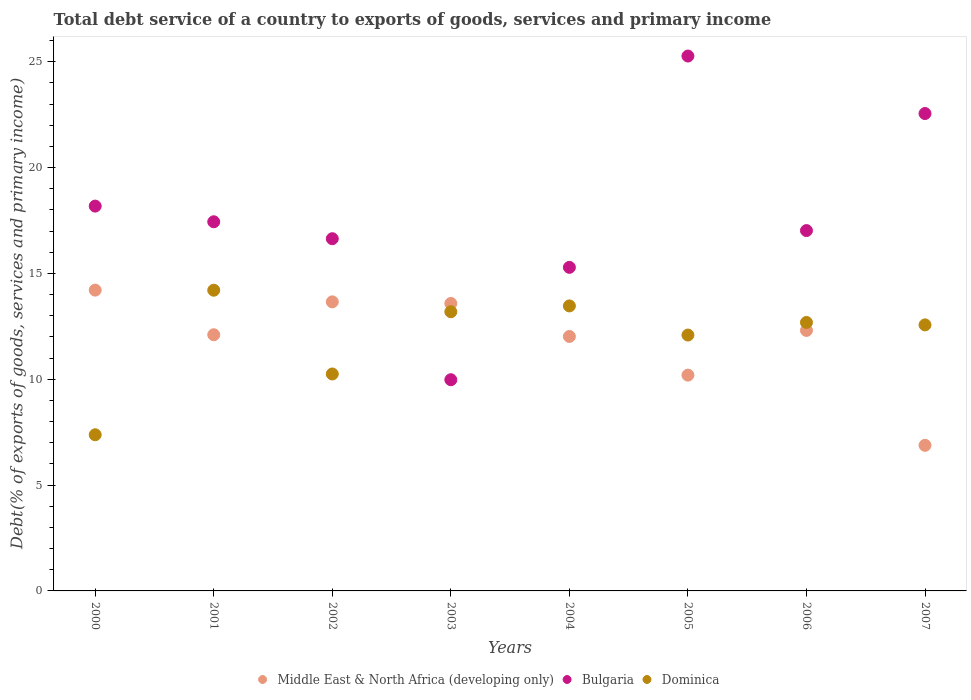Is the number of dotlines equal to the number of legend labels?
Make the answer very short. Yes. What is the total debt service in Bulgaria in 2000?
Your response must be concise. 18.18. Across all years, what is the maximum total debt service in Bulgaria?
Your response must be concise. 25.27. Across all years, what is the minimum total debt service in Bulgaria?
Make the answer very short. 9.98. What is the total total debt service in Middle East & North Africa (developing only) in the graph?
Make the answer very short. 94.96. What is the difference between the total debt service in Middle East & North Africa (developing only) in 2003 and that in 2005?
Your answer should be compact. 3.39. What is the difference between the total debt service in Bulgaria in 2004 and the total debt service in Dominica in 2007?
Provide a succinct answer. 2.72. What is the average total debt service in Bulgaria per year?
Offer a very short reply. 17.8. In the year 2004, what is the difference between the total debt service in Bulgaria and total debt service in Dominica?
Provide a short and direct response. 1.82. In how many years, is the total debt service in Bulgaria greater than 2 %?
Your answer should be compact. 8. What is the ratio of the total debt service in Middle East & North Africa (developing only) in 2003 to that in 2006?
Provide a succinct answer. 1.1. What is the difference between the highest and the second highest total debt service in Middle East & North Africa (developing only)?
Keep it short and to the point. 0.55. What is the difference between the highest and the lowest total debt service in Middle East & North Africa (developing only)?
Provide a short and direct response. 7.33. Does the total debt service in Dominica monotonically increase over the years?
Provide a short and direct response. No. How many years are there in the graph?
Provide a short and direct response. 8. What is the difference between two consecutive major ticks on the Y-axis?
Ensure brevity in your answer.  5. Are the values on the major ticks of Y-axis written in scientific E-notation?
Make the answer very short. No. Where does the legend appear in the graph?
Your answer should be very brief. Bottom center. How many legend labels are there?
Your answer should be compact. 3. What is the title of the graph?
Your response must be concise. Total debt service of a country to exports of goods, services and primary income. Does "Suriname" appear as one of the legend labels in the graph?
Give a very brief answer. No. What is the label or title of the Y-axis?
Keep it short and to the point. Debt(% of exports of goods, services and primary income). What is the Debt(% of exports of goods, services and primary income) of Middle East & North Africa (developing only) in 2000?
Offer a terse response. 14.21. What is the Debt(% of exports of goods, services and primary income) of Bulgaria in 2000?
Provide a short and direct response. 18.18. What is the Debt(% of exports of goods, services and primary income) of Dominica in 2000?
Make the answer very short. 7.38. What is the Debt(% of exports of goods, services and primary income) of Middle East & North Africa (developing only) in 2001?
Offer a terse response. 12.1. What is the Debt(% of exports of goods, services and primary income) of Bulgaria in 2001?
Your response must be concise. 17.44. What is the Debt(% of exports of goods, services and primary income) in Dominica in 2001?
Provide a succinct answer. 14.21. What is the Debt(% of exports of goods, services and primary income) of Middle East & North Africa (developing only) in 2002?
Provide a succinct answer. 13.66. What is the Debt(% of exports of goods, services and primary income) of Bulgaria in 2002?
Make the answer very short. 16.64. What is the Debt(% of exports of goods, services and primary income) in Dominica in 2002?
Offer a very short reply. 10.25. What is the Debt(% of exports of goods, services and primary income) in Middle East & North Africa (developing only) in 2003?
Offer a terse response. 13.58. What is the Debt(% of exports of goods, services and primary income) in Bulgaria in 2003?
Your answer should be compact. 9.98. What is the Debt(% of exports of goods, services and primary income) in Dominica in 2003?
Give a very brief answer. 13.19. What is the Debt(% of exports of goods, services and primary income) of Middle East & North Africa (developing only) in 2004?
Keep it short and to the point. 12.02. What is the Debt(% of exports of goods, services and primary income) in Bulgaria in 2004?
Your response must be concise. 15.29. What is the Debt(% of exports of goods, services and primary income) of Dominica in 2004?
Provide a short and direct response. 13.47. What is the Debt(% of exports of goods, services and primary income) in Middle East & North Africa (developing only) in 2005?
Give a very brief answer. 10.2. What is the Debt(% of exports of goods, services and primary income) of Bulgaria in 2005?
Ensure brevity in your answer.  25.27. What is the Debt(% of exports of goods, services and primary income) in Dominica in 2005?
Make the answer very short. 12.09. What is the Debt(% of exports of goods, services and primary income) in Middle East & North Africa (developing only) in 2006?
Provide a succinct answer. 12.31. What is the Debt(% of exports of goods, services and primary income) in Bulgaria in 2006?
Your answer should be compact. 17.03. What is the Debt(% of exports of goods, services and primary income) of Dominica in 2006?
Your answer should be very brief. 12.68. What is the Debt(% of exports of goods, services and primary income) in Middle East & North Africa (developing only) in 2007?
Provide a succinct answer. 6.88. What is the Debt(% of exports of goods, services and primary income) in Bulgaria in 2007?
Provide a succinct answer. 22.56. What is the Debt(% of exports of goods, services and primary income) in Dominica in 2007?
Ensure brevity in your answer.  12.57. Across all years, what is the maximum Debt(% of exports of goods, services and primary income) of Middle East & North Africa (developing only)?
Provide a short and direct response. 14.21. Across all years, what is the maximum Debt(% of exports of goods, services and primary income) in Bulgaria?
Give a very brief answer. 25.27. Across all years, what is the maximum Debt(% of exports of goods, services and primary income) in Dominica?
Keep it short and to the point. 14.21. Across all years, what is the minimum Debt(% of exports of goods, services and primary income) in Middle East & North Africa (developing only)?
Give a very brief answer. 6.88. Across all years, what is the minimum Debt(% of exports of goods, services and primary income) of Bulgaria?
Provide a succinct answer. 9.98. Across all years, what is the minimum Debt(% of exports of goods, services and primary income) of Dominica?
Your response must be concise. 7.38. What is the total Debt(% of exports of goods, services and primary income) of Middle East & North Africa (developing only) in the graph?
Your answer should be very brief. 94.96. What is the total Debt(% of exports of goods, services and primary income) of Bulgaria in the graph?
Your response must be concise. 142.39. What is the total Debt(% of exports of goods, services and primary income) of Dominica in the graph?
Your response must be concise. 95.84. What is the difference between the Debt(% of exports of goods, services and primary income) in Middle East & North Africa (developing only) in 2000 and that in 2001?
Your answer should be compact. 2.11. What is the difference between the Debt(% of exports of goods, services and primary income) of Bulgaria in 2000 and that in 2001?
Keep it short and to the point. 0.74. What is the difference between the Debt(% of exports of goods, services and primary income) of Dominica in 2000 and that in 2001?
Make the answer very short. -6.83. What is the difference between the Debt(% of exports of goods, services and primary income) in Middle East & North Africa (developing only) in 2000 and that in 2002?
Provide a succinct answer. 0.55. What is the difference between the Debt(% of exports of goods, services and primary income) of Bulgaria in 2000 and that in 2002?
Ensure brevity in your answer.  1.54. What is the difference between the Debt(% of exports of goods, services and primary income) of Dominica in 2000 and that in 2002?
Provide a succinct answer. -2.87. What is the difference between the Debt(% of exports of goods, services and primary income) in Middle East & North Africa (developing only) in 2000 and that in 2003?
Keep it short and to the point. 0.63. What is the difference between the Debt(% of exports of goods, services and primary income) of Bulgaria in 2000 and that in 2003?
Ensure brevity in your answer.  8.2. What is the difference between the Debt(% of exports of goods, services and primary income) in Dominica in 2000 and that in 2003?
Your response must be concise. -5.81. What is the difference between the Debt(% of exports of goods, services and primary income) of Middle East & North Africa (developing only) in 2000 and that in 2004?
Make the answer very short. 2.19. What is the difference between the Debt(% of exports of goods, services and primary income) of Bulgaria in 2000 and that in 2004?
Offer a terse response. 2.89. What is the difference between the Debt(% of exports of goods, services and primary income) of Dominica in 2000 and that in 2004?
Offer a very short reply. -6.09. What is the difference between the Debt(% of exports of goods, services and primary income) of Middle East & North Africa (developing only) in 2000 and that in 2005?
Offer a very short reply. 4.02. What is the difference between the Debt(% of exports of goods, services and primary income) in Bulgaria in 2000 and that in 2005?
Your response must be concise. -7.09. What is the difference between the Debt(% of exports of goods, services and primary income) of Dominica in 2000 and that in 2005?
Offer a terse response. -4.71. What is the difference between the Debt(% of exports of goods, services and primary income) in Middle East & North Africa (developing only) in 2000 and that in 2006?
Keep it short and to the point. 1.91. What is the difference between the Debt(% of exports of goods, services and primary income) in Bulgaria in 2000 and that in 2006?
Provide a short and direct response. 1.16. What is the difference between the Debt(% of exports of goods, services and primary income) in Dominica in 2000 and that in 2006?
Make the answer very short. -5.31. What is the difference between the Debt(% of exports of goods, services and primary income) of Middle East & North Africa (developing only) in 2000 and that in 2007?
Your response must be concise. 7.33. What is the difference between the Debt(% of exports of goods, services and primary income) of Bulgaria in 2000 and that in 2007?
Provide a succinct answer. -4.37. What is the difference between the Debt(% of exports of goods, services and primary income) of Dominica in 2000 and that in 2007?
Keep it short and to the point. -5.19. What is the difference between the Debt(% of exports of goods, services and primary income) of Middle East & North Africa (developing only) in 2001 and that in 2002?
Keep it short and to the point. -1.55. What is the difference between the Debt(% of exports of goods, services and primary income) in Bulgaria in 2001 and that in 2002?
Provide a short and direct response. 0.8. What is the difference between the Debt(% of exports of goods, services and primary income) of Dominica in 2001 and that in 2002?
Provide a short and direct response. 3.96. What is the difference between the Debt(% of exports of goods, services and primary income) in Middle East & North Africa (developing only) in 2001 and that in 2003?
Provide a short and direct response. -1.48. What is the difference between the Debt(% of exports of goods, services and primary income) in Bulgaria in 2001 and that in 2003?
Provide a succinct answer. 7.46. What is the difference between the Debt(% of exports of goods, services and primary income) in Dominica in 2001 and that in 2003?
Provide a succinct answer. 1.02. What is the difference between the Debt(% of exports of goods, services and primary income) in Middle East & North Africa (developing only) in 2001 and that in 2004?
Offer a terse response. 0.08. What is the difference between the Debt(% of exports of goods, services and primary income) in Bulgaria in 2001 and that in 2004?
Your answer should be compact. 2.15. What is the difference between the Debt(% of exports of goods, services and primary income) of Dominica in 2001 and that in 2004?
Offer a very short reply. 0.74. What is the difference between the Debt(% of exports of goods, services and primary income) in Middle East & North Africa (developing only) in 2001 and that in 2005?
Your response must be concise. 1.91. What is the difference between the Debt(% of exports of goods, services and primary income) of Bulgaria in 2001 and that in 2005?
Your answer should be compact. -7.83. What is the difference between the Debt(% of exports of goods, services and primary income) in Dominica in 2001 and that in 2005?
Ensure brevity in your answer.  2.12. What is the difference between the Debt(% of exports of goods, services and primary income) in Middle East & North Africa (developing only) in 2001 and that in 2006?
Offer a very short reply. -0.2. What is the difference between the Debt(% of exports of goods, services and primary income) of Bulgaria in 2001 and that in 2006?
Your answer should be very brief. 0.42. What is the difference between the Debt(% of exports of goods, services and primary income) in Dominica in 2001 and that in 2006?
Offer a very short reply. 1.52. What is the difference between the Debt(% of exports of goods, services and primary income) of Middle East & North Africa (developing only) in 2001 and that in 2007?
Ensure brevity in your answer.  5.22. What is the difference between the Debt(% of exports of goods, services and primary income) in Bulgaria in 2001 and that in 2007?
Offer a very short reply. -5.11. What is the difference between the Debt(% of exports of goods, services and primary income) of Dominica in 2001 and that in 2007?
Give a very brief answer. 1.64. What is the difference between the Debt(% of exports of goods, services and primary income) in Middle East & North Africa (developing only) in 2002 and that in 2003?
Make the answer very short. 0.08. What is the difference between the Debt(% of exports of goods, services and primary income) of Bulgaria in 2002 and that in 2003?
Offer a terse response. 6.66. What is the difference between the Debt(% of exports of goods, services and primary income) in Dominica in 2002 and that in 2003?
Your answer should be compact. -2.94. What is the difference between the Debt(% of exports of goods, services and primary income) in Middle East & North Africa (developing only) in 2002 and that in 2004?
Your answer should be compact. 1.64. What is the difference between the Debt(% of exports of goods, services and primary income) of Bulgaria in 2002 and that in 2004?
Provide a short and direct response. 1.35. What is the difference between the Debt(% of exports of goods, services and primary income) of Dominica in 2002 and that in 2004?
Provide a short and direct response. -3.22. What is the difference between the Debt(% of exports of goods, services and primary income) of Middle East & North Africa (developing only) in 2002 and that in 2005?
Keep it short and to the point. 3.46. What is the difference between the Debt(% of exports of goods, services and primary income) of Bulgaria in 2002 and that in 2005?
Offer a terse response. -8.63. What is the difference between the Debt(% of exports of goods, services and primary income) in Dominica in 2002 and that in 2005?
Make the answer very short. -1.84. What is the difference between the Debt(% of exports of goods, services and primary income) in Middle East & North Africa (developing only) in 2002 and that in 2006?
Give a very brief answer. 1.35. What is the difference between the Debt(% of exports of goods, services and primary income) of Bulgaria in 2002 and that in 2006?
Offer a very short reply. -0.38. What is the difference between the Debt(% of exports of goods, services and primary income) of Dominica in 2002 and that in 2006?
Give a very brief answer. -2.43. What is the difference between the Debt(% of exports of goods, services and primary income) in Middle East & North Africa (developing only) in 2002 and that in 2007?
Offer a very short reply. 6.78. What is the difference between the Debt(% of exports of goods, services and primary income) of Bulgaria in 2002 and that in 2007?
Make the answer very short. -5.91. What is the difference between the Debt(% of exports of goods, services and primary income) of Dominica in 2002 and that in 2007?
Ensure brevity in your answer.  -2.32. What is the difference between the Debt(% of exports of goods, services and primary income) of Middle East & North Africa (developing only) in 2003 and that in 2004?
Your answer should be compact. 1.56. What is the difference between the Debt(% of exports of goods, services and primary income) of Bulgaria in 2003 and that in 2004?
Make the answer very short. -5.31. What is the difference between the Debt(% of exports of goods, services and primary income) in Dominica in 2003 and that in 2004?
Keep it short and to the point. -0.28. What is the difference between the Debt(% of exports of goods, services and primary income) in Middle East & North Africa (developing only) in 2003 and that in 2005?
Ensure brevity in your answer.  3.39. What is the difference between the Debt(% of exports of goods, services and primary income) of Bulgaria in 2003 and that in 2005?
Offer a very short reply. -15.29. What is the difference between the Debt(% of exports of goods, services and primary income) of Dominica in 2003 and that in 2005?
Ensure brevity in your answer.  1.1. What is the difference between the Debt(% of exports of goods, services and primary income) of Middle East & North Africa (developing only) in 2003 and that in 2006?
Provide a short and direct response. 1.28. What is the difference between the Debt(% of exports of goods, services and primary income) in Bulgaria in 2003 and that in 2006?
Ensure brevity in your answer.  -7.05. What is the difference between the Debt(% of exports of goods, services and primary income) of Dominica in 2003 and that in 2006?
Your answer should be compact. 0.51. What is the difference between the Debt(% of exports of goods, services and primary income) in Middle East & North Africa (developing only) in 2003 and that in 2007?
Your answer should be very brief. 6.7. What is the difference between the Debt(% of exports of goods, services and primary income) in Bulgaria in 2003 and that in 2007?
Offer a terse response. -12.58. What is the difference between the Debt(% of exports of goods, services and primary income) of Dominica in 2003 and that in 2007?
Provide a succinct answer. 0.62. What is the difference between the Debt(% of exports of goods, services and primary income) of Middle East & North Africa (developing only) in 2004 and that in 2005?
Make the answer very short. 1.83. What is the difference between the Debt(% of exports of goods, services and primary income) in Bulgaria in 2004 and that in 2005?
Your response must be concise. -9.98. What is the difference between the Debt(% of exports of goods, services and primary income) of Dominica in 2004 and that in 2005?
Offer a very short reply. 1.38. What is the difference between the Debt(% of exports of goods, services and primary income) of Middle East & North Africa (developing only) in 2004 and that in 2006?
Your answer should be compact. -0.28. What is the difference between the Debt(% of exports of goods, services and primary income) of Bulgaria in 2004 and that in 2006?
Offer a very short reply. -1.74. What is the difference between the Debt(% of exports of goods, services and primary income) in Dominica in 2004 and that in 2006?
Offer a terse response. 0.78. What is the difference between the Debt(% of exports of goods, services and primary income) of Middle East & North Africa (developing only) in 2004 and that in 2007?
Offer a very short reply. 5.14. What is the difference between the Debt(% of exports of goods, services and primary income) in Bulgaria in 2004 and that in 2007?
Make the answer very short. -7.27. What is the difference between the Debt(% of exports of goods, services and primary income) in Dominica in 2004 and that in 2007?
Make the answer very short. 0.9. What is the difference between the Debt(% of exports of goods, services and primary income) in Middle East & North Africa (developing only) in 2005 and that in 2006?
Your answer should be very brief. -2.11. What is the difference between the Debt(% of exports of goods, services and primary income) in Bulgaria in 2005 and that in 2006?
Keep it short and to the point. 8.25. What is the difference between the Debt(% of exports of goods, services and primary income) of Dominica in 2005 and that in 2006?
Keep it short and to the point. -0.6. What is the difference between the Debt(% of exports of goods, services and primary income) of Middle East & North Africa (developing only) in 2005 and that in 2007?
Your answer should be very brief. 3.32. What is the difference between the Debt(% of exports of goods, services and primary income) of Bulgaria in 2005 and that in 2007?
Make the answer very short. 2.72. What is the difference between the Debt(% of exports of goods, services and primary income) of Dominica in 2005 and that in 2007?
Your answer should be very brief. -0.48. What is the difference between the Debt(% of exports of goods, services and primary income) of Middle East & North Africa (developing only) in 2006 and that in 2007?
Give a very brief answer. 5.43. What is the difference between the Debt(% of exports of goods, services and primary income) in Bulgaria in 2006 and that in 2007?
Your answer should be very brief. -5.53. What is the difference between the Debt(% of exports of goods, services and primary income) in Dominica in 2006 and that in 2007?
Provide a succinct answer. 0.11. What is the difference between the Debt(% of exports of goods, services and primary income) of Middle East & North Africa (developing only) in 2000 and the Debt(% of exports of goods, services and primary income) of Bulgaria in 2001?
Ensure brevity in your answer.  -3.23. What is the difference between the Debt(% of exports of goods, services and primary income) in Middle East & North Africa (developing only) in 2000 and the Debt(% of exports of goods, services and primary income) in Dominica in 2001?
Your answer should be compact. 0. What is the difference between the Debt(% of exports of goods, services and primary income) of Bulgaria in 2000 and the Debt(% of exports of goods, services and primary income) of Dominica in 2001?
Keep it short and to the point. 3.97. What is the difference between the Debt(% of exports of goods, services and primary income) of Middle East & North Africa (developing only) in 2000 and the Debt(% of exports of goods, services and primary income) of Bulgaria in 2002?
Give a very brief answer. -2.43. What is the difference between the Debt(% of exports of goods, services and primary income) in Middle East & North Africa (developing only) in 2000 and the Debt(% of exports of goods, services and primary income) in Dominica in 2002?
Make the answer very short. 3.96. What is the difference between the Debt(% of exports of goods, services and primary income) in Bulgaria in 2000 and the Debt(% of exports of goods, services and primary income) in Dominica in 2002?
Make the answer very short. 7.93. What is the difference between the Debt(% of exports of goods, services and primary income) in Middle East & North Africa (developing only) in 2000 and the Debt(% of exports of goods, services and primary income) in Bulgaria in 2003?
Your response must be concise. 4.23. What is the difference between the Debt(% of exports of goods, services and primary income) in Middle East & North Africa (developing only) in 2000 and the Debt(% of exports of goods, services and primary income) in Dominica in 2003?
Your answer should be compact. 1.02. What is the difference between the Debt(% of exports of goods, services and primary income) in Bulgaria in 2000 and the Debt(% of exports of goods, services and primary income) in Dominica in 2003?
Ensure brevity in your answer.  4.99. What is the difference between the Debt(% of exports of goods, services and primary income) of Middle East & North Africa (developing only) in 2000 and the Debt(% of exports of goods, services and primary income) of Bulgaria in 2004?
Give a very brief answer. -1.08. What is the difference between the Debt(% of exports of goods, services and primary income) in Middle East & North Africa (developing only) in 2000 and the Debt(% of exports of goods, services and primary income) in Dominica in 2004?
Provide a short and direct response. 0.75. What is the difference between the Debt(% of exports of goods, services and primary income) of Bulgaria in 2000 and the Debt(% of exports of goods, services and primary income) of Dominica in 2004?
Make the answer very short. 4.72. What is the difference between the Debt(% of exports of goods, services and primary income) of Middle East & North Africa (developing only) in 2000 and the Debt(% of exports of goods, services and primary income) of Bulgaria in 2005?
Offer a terse response. -11.06. What is the difference between the Debt(% of exports of goods, services and primary income) of Middle East & North Africa (developing only) in 2000 and the Debt(% of exports of goods, services and primary income) of Dominica in 2005?
Offer a very short reply. 2.12. What is the difference between the Debt(% of exports of goods, services and primary income) in Bulgaria in 2000 and the Debt(% of exports of goods, services and primary income) in Dominica in 2005?
Keep it short and to the point. 6.09. What is the difference between the Debt(% of exports of goods, services and primary income) in Middle East & North Africa (developing only) in 2000 and the Debt(% of exports of goods, services and primary income) in Bulgaria in 2006?
Make the answer very short. -2.81. What is the difference between the Debt(% of exports of goods, services and primary income) of Middle East & North Africa (developing only) in 2000 and the Debt(% of exports of goods, services and primary income) of Dominica in 2006?
Your answer should be very brief. 1.53. What is the difference between the Debt(% of exports of goods, services and primary income) of Bulgaria in 2000 and the Debt(% of exports of goods, services and primary income) of Dominica in 2006?
Keep it short and to the point. 5.5. What is the difference between the Debt(% of exports of goods, services and primary income) in Middle East & North Africa (developing only) in 2000 and the Debt(% of exports of goods, services and primary income) in Bulgaria in 2007?
Provide a succinct answer. -8.34. What is the difference between the Debt(% of exports of goods, services and primary income) of Middle East & North Africa (developing only) in 2000 and the Debt(% of exports of goods, services and primary income) of Dominica in 2007?
Your answer should be compact. 1.64. What is the difference between the Debt(% of exports of goods, services and primary income) in Bulgaria in 2000 and the Debt(% of exports of goods, services and primary income) in Dominica in 2007?
Provide a succinct answer. 5.61. What is the difference between the Debt(% of exports of goods, services and primary income) of Middle East & North Africa (developing only) in 2001 and the Debt(% of exports of goods, services and primary income) of Bulgaria in 2002?
Provide a succinct answer. -4.54. What is the difference between the Debt(% of exports of goods, services and primary income) of Middle East & North Africa (developing only) in 2001 and the Debt(% of exports of goods, services and primary income) of Dominica in 2002?
Your response must be concise. 1.85. What is the difference between the Debt(% of exports of goods, services and primary income) in Bulgaria in 2001 and the Debt(% of exports of goods, services and primary income) in Dominica in 2002?
Make the answer very short. 7.19. What is the difference between the Debt(% of exports of goods, services and primary income) in Middle East & North Africa (developing only) in 2001 and the Debt(% of exports of goods, services and primary income) in Bulgaria in 2003?
Offer a very short reply. 2.12. What is the difference between the Debt(% of exports of goods, services and primary income) in Middle East & North Africa (developing only) in 2001 and the Debt(% of exports of goods, services and primary income) in Dominica in 2003?
Offer a very short reply. -1.09. What is the difference between the Debt(% of exports of goods, services and primary income) in Bulgaria in 2001 and the Debt(% of exports of goods, services and primary income) in Dominica in 2003?
Offer a terse response. 4.25. What is the difference between the Debt(% of exports of goods, services and primary income) of Middle East & North Africa (developing only) in 2001 and the Debt(% of exports of goods, services and primary income) of Bulgaria in 2004?
Your answer should be compact. -3.18. What is the difference between the Debt(% of exports of goods, services and primary income) in Middle East & North Africa (developing only) in 2001 and the Debt(% of exports of goods, services and primary income) in Dominica in 2004?
Give a very brief answer. -1.36. What is the difference between the Debt(% of exports of goods, services and primary income) of Bulgaria in 2001 and the Debt(% of exports of goods, services and primary income) of Dominica in 2004?
Offer a terse response. 3.98. What is the difference between the Debt(% of exports of goods, services and primary income) in Middle East & North Africa (developing only) in 2001 and the Debt(% of exports of goods, services and primary income) in Bulgaria in 2005?
Provide a short and direct response. -13.17. What is the difference between the Debt(% of exports of goods, services and primary income) of Middle East & North Africa (developing only) in 2001 and the Debt(% of exports of goods, services and primary income) of Dominica in 2005?
Ensure brevity in your answer.  0.01. What is the difference between the Debt(% of exports of goods, services and primary income) in Bulgaria in 2001 and the Debt(% of exports of goods, services and primary income) in Dominica in 2005?
Provide a short and direct response. 5.35. What is the difference between the Debt(% of exports of goods, services and primary income) in Middle East & North Africa (developing only) in 2001 and the Debt(% of exports of goods, services and primary income) in Bulgaria in 2006?
Provide a short and direct response. -4.92. What is the difference between the Debt(% of exports of goods, services and primary income) in Middle East & North Africa (developing only) in 2001 and the Debt(% of exports of goods, services and primary income) in Dominica in 2006?
Your response must be concise. -0.58. What is the difference between the Debt(% of exports of goods, services and primary income) in Bulgaria in 2001 and the Debt(% of exports of goods, services and primary income) in Dominica in 2006?
Your answer should be compact. 4.76. What is the difference between the Debt(% of exports of goods, services and primary income) of Middle East & North Africa (developing only) in 2001 and the Debt(% of exports of goods, services and primary income) of Bulgaria in 2007?
Your answer should be very brief. -10.45. What is the difference between the Debt(% of exports of goods, services and primary income) in Middle East & North Africa (developing only) in 2001 and the Debt(% of exports of goods, services and primary income) in Dominica in 2007?
Your response must be concise. -0.47. What is the difference between the Debt(% of exports of goods, services and primary income) in Bulgaria in 2001 and the Debt(% of exports of goods, services and primary income) in Dominica in 2007?
Provide a short and direct response. 4.87. What is the difference between the Debt(% of exports of goods, services and primary income) in Middle East & North Africa (developing only) in 2002 and the Debt(% of exports of goods, services and primary income) in Bulgaria in 2003?
Your response must be concise. 3.68. What is the difference between the Debt(% of exports of goods, services and primary income) of Middle East & North Africa (developing only) in 2002 and the Debt(% of exports of goods, services and primary income) of Dominica in 2003?
Your answer should be very brief. 0.47. What is the difference between the Debt(% of exports of goods, services and primary income) in Bulgaria in 2002 and the Debt(% of exports of goods, services and primary income) in Dominica in 2003?
Provide a succinct answer. 3.45. What is the difference between the Debt(% of exports of goods, services and primary income) in Middle East & North Africa (developing only) in 2002 and the Debt(% of exports of goods, services and primary income) in Bulgaria in 2004?
Provide a succinct answer. -1.63. What is the difference between the Debt(% of exports of goods, services and primary income) in Middle East & North Africa (developing only) in 2002 and the Debt(% of exports of goods, services and primary income) in Dominica in 2004?
Offer a terse response. 0.19. What is the difference between the Debt(% of exports of goods, services and primary income) of Bulgaria in 2002 and the Debt(% of exports of goods, services and primary income) of Dominica in 2004?
Ensure brevity in your answer.  3.18. What is the difference between the Debt(% of exports of goods, services and primary income) of Middle East & North Africa (developing only) in 2002 and the Debt(% of exports of goods, services and primary income) of Bulgaria in 2005?
Offer a terse response. -11.61. What is the difference between the Debt(% of exports of goods, services and primary income) in Middle East & North Africa (developing only) in 2002 and the Debt(% of exports of goods, services and primary income) in Dominica in 2005?
Your response must be concise. 1.57. What is the difference between the Debt(% of exports of goods, services and primary income) of Bulgaria in 2002 and the Debt(% of exports of goods, services and primary income) of Dominica in 2005?
Give a very brief answer. 4.55. What is the difference between the Debt(% of exports of goods, services and primary income) in Middle East & North Africa (developing only) in 2002 and the Debt(% of exports of goods, services and primary income) in Bulgaria in 2006?
Give a very brief answer. -3.37. What is the difference between the Debt(% of exports of goods, services and primary income) of Middle East & North Africa (developing only) in 2002 and the Debt(% of exports of goods, services and primary income) of Dominica in 2006?
Your answer should be very brief. 0.97. What is the difference between the Debt(% of exports of goods, services and primary income) of Bulgaria in 2002 and the Debt(% of exports of goods, services and primary income) of Dominica in 2006?
Your response must be concise. 3.96. What is the difference between the Debt(% of exports of goods, services and primary income) in Middle East & North Africa (developing only) in 2002 and the Debt(% of exports of goods, services and primary income) in Bulgaria in 2007?
Provide a succinct answer. -8.9. What is the difference between the Debt(% of exports of goods, services and primary income) of Middle East & North Africa (developing only) in 2002 and the Debt(% of exports of goods, services and primary income) of Dominica in 2007?
Provide a short and direct response. 1.09. What is the difference between the Debt(% of exports of goods, services and primary income) of Bulgaria in 2002 and the Debt(% of exports of goods, services and primary income) of Dominica in 2007?
Offer a very short reply. 4.07. What is the difference between the Debt(% of exports of goods, services and primary income) of Middle East & North Africa (developing only) in 2003 and the Debt(% of exports of goods, services and primary income) of Bulgaria in 2004?
Provide a succinct answer. -1.71. What is the difference between the Debt(% of exports of goods, services and primary income) of Middle East & North Africa (developing only) in 2003 and the Debt(% of exports of goods, services and primary income) of Dominica in 2004?
Your answer should be compact. 0.12. What is the difference between the Debt(% of exports of goods, services and primary income) in Bulgaria in 2003 and the Debt(% of exports of goods, services and primary income) in Dominica in 2004?
Provide a short and direct response. -3.49. What is the difference between the Debt(% of exports of goods, services and primary income) of Middle East & North Africa (developing only) in 2003 and the Debt(% of exports of goods, services and primary income) of Bulgaria in 2005?
Offer a terse response. -11.69. What is the difference between the Debt(% of exports of goods, services and primary income) of Middle East & North Africa (developing only) in 2003 and the Debt(% of exports of goods, services and primary income) of Dominica in 2005?
Give a very brief answer. 1.49. What is the difference between the Debt(% of exports of goods, services and primary income) of Bulgaria in 2003 and the Debt(% of exports of goods, services and primary income) of Dominica in 2005?
Keep it short and to the point. -2.11. What is the difference between the Debt(% of exports of goods, services and primary income) of Middle East & North Africa (developing only) in 2003 and the Debt(% of exports of goods, services and primary income) of Bulgaria in 2006?
Ensure brevity in your answer.  -3.44. What is the difference between the Debt(% of exports of goods, services and primary income) in Middle East & North Africa (developing only) in 2003 and the Debt(% of exports of goods, services and primary income) in Dominica in 2006?
Offer a very short reply. 0.9. What is the difference between the Debt(% of exports of goods, services and primary income) of Bulgaria in 2003 and the Debt(% of exports of goods, services and primary income) of Dominica in 2006?
Make the answer very short. -2.71. What is the difference between the Debt(% of exports of goods, services and primary income) in Middle East & North Africa (developing only) in 2003 and the Debt(% of exports of goods, services and primary income) in Bulgaria in 2007?
Give a very brief answer. -8.97. What is the difference between the Debt(% of exports of goods, services and primary income) in Middle East & North Africa (developing only) in 2003 and the Debt(% of exports of goods, services and primary income) in Dominica in 2007?
Provide a short and direct response. 1.01. What is the difference between the Debt(% of exports of goods, services and primary income) of Bulgaria in 2003 and the Debt(% of exports of goods, services and primary income) of Dominica in 2007?
Offer a terse response. -2.59. What is the difference between the Debt(% of exports of goods, services and primary income) in Middle East & North Africa (developing only) in 2004 and the Debt(% of exports of goods, services and primary income) in Bulgaria in 2005?
Your answer should be very brief. -13.25. What is the difference between the Debt(% of exports of goods, services and primary income) in Middle East & North Africa (developing only) in 2004 and the Debt(% of exports of goods, services and primary income) in Dominica in 2005?
Make the answer very short. -0.07. What is the difference between the Debt(% of exports of goods, services and primary income) of Bulgaria in 2004 and the Debt(% of exports of goods, services and primary income) of Dominica in 2005?
Give a very brief answer. 3.2. What is the difference between the Debt(% of exports of goods, services and primary income) in Middle East & North Africa (developing only) in 2004 and the Debt(% of exports of goods, services and primary income) in Bulgaria in 2006?
Make the answer very short. -5. What is the difference between the Debt(% of exports of goods, services and primary income) in Middle East & North Africa (developing only) in 2004 and the Debt(% of exports of goods, services and primary income) in Dominica in 2006?
Ensure brevity in your answer.  -0.66. What is the difference between the Debt(% of exports of goods, services and primary income) of Bulgaria in 2004 and the Debt(% of exports of goods, services and primary income) of Dominica in 2006?
Give a very brief answer. 2.6. What is the difference between the Debt(% of exports of goods, services and primary income) in Middle East & North Africa (developing only) in 2004 and the Debt(% of exports of goods, services and primary income) in Bulgaria in 2007?
Keep it short and to the point. -10.53. What is the difference between the Debt(% of exports of goods, services and primary income) in Middle East & North Africa (developing only) in 2004 and the Debt(% of exports of goods, services and primary income) in Dominica in 2007?
Your answer should be compact. -0.55. What is the difference between the Debt(% of exports of goods, services and primary income) of Bulgaria in 2004 and the Debt(% of exports of goods, services and primary income) of Dominica in 2007?
Make the answer very short. 2.72. What is the difference between the Debt(% of exports of goods, services and primary income) of Middle East & North Africa (developing only) in 2005 and the Debt(% of exports of goods, services and primary income) of Bulgaria in 2006?
Offer a very short reply. -6.83. What is the difference between the Debt(% of exports of goods, services and primary income) of Middle East & North Africa (developing only) in 2005 and the Debt(% of exports of goods, services and primary income) of Dominica in 2006?
Keep it short and to the point. -2.49. What is the difference between the Debt(% of exports of goods, services and primary income) in Bulgaria in 2005 and the Debt(% of exports of goods, services and primary income) in Dominica in 2006?
Offer a terse response. 12.59. What is the difference between the Debt(% of exports of goods, services and primary income) of Middle East & North Africa (developing only) in 2005 and the Debt(% of exports of goods, services and primary income) of Bulgaria in 2007?
Give a very brief answer. -12.36. What is the difference between the Debt(% of exports of goods, services and primary income) of Middle East & North Africa (developing only) in 2005 and the Debt(% of exports of goods, services and primary income) of Dominica in 2007?
Provide a short and direct response. -2.37. What is the difference between the Debt(% of exports of goods, services and primary income) of Bulgaria in 2005 and the Debt(% of exports of goods, services and primary income) of Dominica in 2007?
Offer a terse response. 12.7. What is the difference between the Debt(% of exports of goods, services and primary income) in Middle East & North Africa (developing only) in 2006 and the Debt(% of exports of goods, services and primary income) in Bulgaria in 2007?
Your answer should be compact. -10.25. What is the difference between the Debt(% of exports of goods, services and primary income) in Middle East & North Africa (developing only) in 2006 and the Debt(% of exports of goods, services and primary income) in Dominica in 2007?
Provide a succinct answer. -0.26. What is the difference between the Debt(% of exports of goods, services and primary income) in Bulgaria in 2006 and the Debt(% of exports of goods, services and primary income) in Dominica in 2007?
Offer a terse response. 4.46. What is the average Debt(% of exports of goods, services and primary income) of Middle East & North Africa (developing only) per year?
Ensure brevity in your answer.  11.87. What is the average Debt(% of exports of goods, services and primary income) of Bulgaria per year?
Your response must be concise. 17.8. What is the average Debt(% of exports of goods, services and primary income) in Dominica per year?
Provide a succinct answer. 11.98. In the year 2000, what is the difference between the Debt(% of exports of goods, services and primary income) of Middle East & North Africa (developing only) and Debt(% of exports of goods, services and primary income) of Bulgaria?
Your response must be concise. -3.97. In the year 2000, what is the difference between the Debt(% of exports of goods, services and primary income) in Middle East & North Africa (developing only) and Debt(% of exports of goods, services and primary income) in Dominica?
Keep it short and to the point. 6.83. In the year 2000, what is the difference between the Debt(% of exports of goods, services and primary income) in Bulgaria and Debt(% of exports of goods, services and primary income) in Dominica?
Offer a very short reply. 10.8. In the year 2001, what is the difference between the Debt(% of exports of goods, services and primary income) of Middle East & North Africa (developing only) and Debt(% of exports of goods, services and primary income) of Bulgaria?
Ensure brevity in your answer.  -5.34. In the year 2001, what is the difference between the Debt(% of exports of goods, services and primary income) of Middle East & North Africa (developing only) and Debt(% of exports of goods, services and primary income) of Dominica?
Offer a very short reply. -2.1. In the year 2001, what is the difference between the Debt(% of exports of goods, services and primary income) in Bulgaria and Debt(% of exports of goods, services and primary income) in Dominica?
Your answer should be compact. 3.23. In the year 2002, what is the difference between the Debt(% of exports of goods, services and primary income) of Middle East & North Africa (developing only) and Debt(% of exports of goods, services and primary income) of Bulgaria?
Your response must be concise. -2.98. In the year 2002, what is the difference between the Debt(% of exports of goods, services and primary income) of Middle East & North Africa (developing only) and Debt(% of exports of goods, services and primary income) of Dominica?
Provide a short and direct response. 3.41. In the year 2002, what is the difference between the Debt(% of exports of goods, services and primary income) of Bulgaria and Debt(% of exports of goods, services and primary income) of Dominica?
Offer a very short reply. 6.39. In the year 2003, what is the difference between the Debt(% of exports of goods, services and primary income) of Middle East & North Africa (developing only) and Debt(% of exports of goods, services and primary income) of Bulgaria?
Give a very brief answer. 3.6. In the year 2003, what is the difference between the Debt(% of exports of goods, services and primary income) in Middle East & North Africa (developing only) and Debt(% of exports of goods, services and primary income) in Dominica?
Make the answer very short. 0.39. In the year 2003, what is the difference between the Debt(% of exports of goods, services and primary income) of Bulgaria and Debt(% of exports of goods, services and primary income) of Dominica?
Keep it short and to the point. -3.21. In the year 2004, what is the difference between the Debt(% of exports of goods, services and primary income) in Middle East & North Africa (developing only) and Debt(% of exports of goods, services and primary income) in Bulgaria?
Give a very brief answer. -3.27. In the year 2004, what is the difference between the Debt(% of exports of goods, services and primary income) of Middle East & North Africa (developing only) and Debt(% of exports of goods, services and primary income) of Dominica?
Your answer should be very brief. -1.44. In the year 2004, what is the difference between the Debt(% of exports of goods, services and primary income) of Bulgaria and Debt(% of exports of goods, services and primary income) of Dominica?
Offer a terse response. 1.82. In the year 2005, what is the difference between the Debt(% of exports of goods, services and primary income) in Middle East & North Africa (developing only) and Debt(% of exports of goods, services and primary income) in Bulgaria?
Make the answer very short. -15.08. In the year 2005, what is the difference between the Debt(% of exports of goods, services and primary income) of Middle East & North Africa (developing only) and Debt(% of exports of goods, services and primary income) of Dominica?
Your response must be concise. -1.89. In the year 2005, what is the difference between the Debt(% of exports of goods, services and primary income) of Bulgaria and Debt(% of exports of goods, services and primary income) of Dominica?
Give a very brief answer. 13.18. In the year 2006, what is the difference between the Debt(% of exports of goods, services and primary income) of Middle East & North Africa (developing only) and Debt(% of exports of goods, services and primary income) of Bulgaria?
Make the answer very short. -4.72. In the year 2006, what is the difference between the Debt(% of exports of goods, services and primary income) of Middle East & North Africa (developing only) and Debt(% of exports of goods, services and primary income) of Dominica?
Provide a short and direct response. -0.38. In the year 2006, what is the difference between the Debt(% of exports of goods, services and primary income) in Bulgaria and Debt(% of exports of goods, services and primary income) in Dominica?
Provide a short and direct response. 4.34. In the year 2007, what is the difference between the Debt(% of exports of goods, services and primary income) of Middle East & North Africa (developing only) and Debt(% of exports of goods, services and primary income) of Bulgaria?
Provide a short and direct response. -15.68. In the year 2007, what is the difference between the Debt(% of exports of goods, services and primary income) in Middle East & North Africa (developing only) and Debt(% of exports of goods, services and primary income) in Dominica?
Your answer should be compact. -5.69. In the year 2007, what is the difference between the Debt(% of exports of goods, services and primary income) in Bulgaria and Debt(% of exports of goods, services and primary income) in Dominica?
Provide a succinct answer. 9.99. What is the ratio of the Debt(% of exports of goods, services and primary income) in Middle East & North Africa (developing only) in 2000 to that in 2001?
Offer a very short reply. 1.17. What is the ratio of the Debt(% of exports of goods, services and primary income) of Bulgaria in 2000 to that in 2001?
Offer a terse response. 1.04. What is the ratio of the Debt(% of exports of goods, services and primary income) of Dominica in 2000 to that in 2001?
Offer a terse response. 0.52. What is the ratio of the Debt(% of exports of goods, services and primary income) of Middle East & North Africa (developing only) in 2000 to that in 2002?
Offer a terse response. 1.04. What is the ratio of the Debt(% of exports of goods, services and primary income) of Bulgaria in 2000 to that in 2002?
Your response must be concise. 1.09. What is the ratio of the Debt(% of exports of goods, services and primary income) in Dominica in 2000 to that in 2002?
Your answer should be compact. 0.72. What is the ratio of the Debt(% of exports of goods, services and primary income) of Middle East & North Africa (developing only) in 2000 to that in 2003?
Provide a succinct answer. 1.05. What is the ratio of the Debt(% of exports of goods, services and primary income) in Bulgaria in 2000 to that in 2003?
Give a very brief answer. 1.82. What is the ratio of the Debt(% of exports of goods, services and primary income) in Dominica in 2000 to that in 2003?
Make the answer very short. 0.56. What is the ratio of the Debt(% of exports of goods, services and primary income) of Middle East & North Africa (developing only) in 2000 to that in 2004?
Your answer should be compact. 1.18. What is the ratio of the Debt(% of exports of goods, services and primary income) of Bulgaria in 2000 to that in 2004?
Provide a short and direct response. 1.19. What is the ratio of the Debt(% of exports of goods, services and primary income) of Dominica in 2000 to that in 2004?
Give a very brief answer. 0.55. What is the ratio of the Debt(% of exports of goods, services and primary income) in Middle East & North Africa (developing only) in 2000 to that in 2005?
Make the answer very short. 1.39. What is the ratio of the Debt(% of exports of goods, services and primary income) of Bulgaria in 2000 to that in 2005?
Offer a terse response. 0.72. What is the ratio of the Debt(% of exports of goods, services and primary income) of Dominica in 2000 to that in 2005?
Give a very brief answer. 0.61. What is the ratio of the Debt(% of exports of goods, services and primary income) of Middle East & North Africa (developing only) in 2000 to that in 2006?
Ensure brevity in your answer.  1.15. What is the ratio of the Debt(% of exports of goods, services and primary income) in Bulgaria in 2000 to that in 2006?
Your answer should be compact. 1.07. What is the ratio of the Debt(% of exports of goods, services and primary income) of Dominica in 2000 to that in 2006?
Provide a succinct answer. 0.58. What is the ratio of the Debt(% of exports of goods, services and primary income) of Middle East & North Africa (developing only) in 2000 to that in 2007?
Offer a very short reply. 2.07. What is the ratio of the Debt(% of exports of goods, services and primary income) of Bulgaria in 2000 to that in 2007?
Your answer should be very brief. 0.81. What is the ratio of the Debt(% of exports of goods, services and primary income) of Dominica in 2000 to that in 2007?
Give a very brief answer. 0.59. What is the ratio of the Debt(% of exports of goods, services and primary income) in Middle East & North Africa (developing only) in 2001 to that in 2002?
Your response must be concise. 0.89. What is the ratio of the Debt(% of exports of goods, services and primary income) of Bulgaria in 2001 to that in 2002?
Keep it short and to the point. 1.05. What is the ratio of the Debt(% of exports of goods, services and primary income) of Dominica in 2001 to that in 2002?
Make the answer very short. 1.39. What is the ratio of the Debt(% of exports of goods, services and primary income) of Middle East & North Africa (developing only) in 2001 to that in 2003?
Offer a very short reply. 0.89. What is the ratio of the Debt(% of exports of goods, services and primary income) in Bulgaria in 2001 to that in 2003?
Offer a very short reply. 1.75. What is the ratio of the Debt(% of exports of goods, services and primary income) of Dominica in 2001 to that in 2003?
Offer a very short reply. 1.08. What is the ratio of the Debt(% of exports of goods, services and primary income) of Bulgaria in 2001 to that in 2004?
Your answer should be compact. 1.14. What is the ratio of the Debt(% of exports of goods, services and primary income) in Dominica in 2001 to that in 2004?
Provide a succinct answer. 1.06. What is the ratio of the Debt(% of exports of goods, services and primary income) in Middle East & North Africa (developing only) in 2001 to that in 2005?
Ensure brevity in your answer.  1.19. What is the ratio of the Debt(% of exports of goods, services and primary income) of Bulgaria in 2001 to that in 2005?
Ensure brevity in your answer.  0.69. What is the ratio of the Debt(% of exports of goods, services and primary income) of Dominica in 2001 to that in 2005?
Keep it short and to the point. 1.18. What is the ratio of the Debt(% of exports of goods, services and primary income) of Middle East & North Africa (developing only) in 2001 to that in 2006?
Offer a very short reply. 0.98. What is the ratio of the Debt(% of exports of goods, services and primary income) in Bulgaria in 2001 to that in 2006?
Keep it short and to the point. 1.02. What is the ratio of the Debt(% of exports of goods, services and primary income) in Dominica in 2001 to that in 2006?
Your answer should be very brief. 1.12. What is the ratio of the Debt(% of exports of goods, services and primary income) of Middle East & North Africa (developing only) in 2001 to that in 2007?
Make the answer very short. 1.76. What is the ratio of the Debt(% of exports of goods, services and primary income) of Bulgaria in 2001 to that in 2007?
Your response must be concise. 0.77. What is the ratio of the Debt(% of exports of goods, services and primary income) of Dominica in 2001 to that in 2007?
Make the answer very short. 1.13. What is the ratio of the Debt(% of exports of goods, services and primary income) of Middle East & North Africa (developing only) in 2002 to that in 2003?
Offer a very short reply. 1.01. What is the ratio of the Debt(% of exports of goods, services and primary income) in Bulgaria in 2002 to that in 2003?
Provide a short and direct response. 1.67. What is the ratio of the Debt(% of exports of goods, services and primary income) in Dominica in 2002 to that in 2003?
Your answer should be very brief. 0.78. What is the ratio of the Debt(% of exports of goods, services and primary income) of Middle East & North Africa (developing only) in 2002 to that in 2004?
Your answer should be compact. 1.14. What is the ratio of the Debt(% of exports of goods, services and primary income) of Bulgaria in 2002 to that in 2004?
Offer a terse response. 1.09. What is the ratio of the Debt(% of exports of goods, services and primary income) in Dominica in 2002 to that in 2004?
Make the answer very short. 0.76. What is the ratio of the Debt(% of exports of goods, services and primary income) of Middle East & North Africa (developing only) in 2002 to that in 2005?
Give a very brief answer. 1.34. What is the ratio of the Debt(% of exports of goods, services and primary income) in Bulgaria in 2002 to that in 2005?
Give a very brief answer. 0.66. What is the ratio of the Debt(% of exports of goods, services and primary income) in Dominica in 2002 to that in 2005?
Offer a very short reply. 0.85. What is the ratio of the Debt(% of exports of goods, services and primary income) in Middle East & North Africa (developing only) in 2002 to that in 2006?
Ensure brevity in your answer.  1.11. What is the ratio of the Debt(% of exports of goods, services and primary income) of Bulgaria in 2002 to that in 2006?
Provide a short and direct response. 0.98. What is the ratio of the Debt(% of exports of goods, services and primary income) of Dominica in 2002 to that in 2006?
Provide a succinct answer. 0.81. What is the ratio of the Debt(% of exports of goods, services and primary income) of Middle East & North Africa (developing only) in 2002 to that in 2007?
Offer a very short reply. 1.99. What is the ratio of the Debt(% of exports of goods, services and primary income) of Bulgaria in 2002 to that in 2007?
Offer a terse response. 0.74. What is the ratio of the Debt(% of exports of goods, services and primary income) of Dominica in 2002 to that in 2007?
Your answer should be very brief. 0.82. What is the ratio of the Debt(% of exports of goods, services and primary income) in Middle East & North Africa (developing only) in 2003 to that in 2004?
Provide a succinct answer. 1.13. What is the ratio of the Debt(% of exports of goods, services and primary income) in Bulgaria in 2003 to that in 2004?
Offer a terse response. 0.65. What is the ratio of the Debt(% of exports of goods, services and primary income) in Dominica in 2003 to that in 2004?
Keep it short and to the point. 0.98. What is the ratio of the Debt(% of exports of goods, services and primary income) of Middle East & North Africa (developing only) in 2003 to that in 2005?
Provide a succinct answer. 1.33. What is the ratio of the Debt(% of exports of goods, services and primary income) of Bulgaria in 2003 to that in 2005?
Offer a very short reply. 0.39. What is the ratio of the Debt(% of exports of goods, services and primary income) of Dominica in 2003 to that in 2005?
Keep it short and to the point. 1.09. What is the ratio of the Debt(% of exports of goods, services and primary income) of Middle East & North Africa (developing only) in 2003 to that in 2006?
Offer a terse response. 1.1. What is the ratio of the Debt(% of exports of goods, services and primary income) in Bulgaria in 2003 to that in 2006?
Your response must be concise. 0.59. What is the ratio of the Debt(% of exports of goods, services and primary income) in Dominica in 2003 to that in 2006?
Offer a terse response. 1.04. What is the ratio of the Debt(% of exports of goods, services and primary income) of Middle East & North Africa (developing only) in 2003 to that in 2007?
Ensure brevity in your answer.  1.97. What is the ratio of the Debt(% of exports of goods, services and primary income) in Bulgaria in 2003 to that in 2007?
Keep it short and to the point. 0.44. What is the ratio of the Debt(% of exports of goods, services and primary income) in Dominica in 2003 to that in 2007?
Make the answer very short. 1.05. What is the ratio of the Debt(% of exports of goods, services and primary income) of Middle East & North Africa (developing only) in 2004 to that in 2005?
Provide a succinct answer. 1.18. What is the ratio of the Debt(% of exports of goods, services and primary income) of Bulgaria in 2004 to that in 2005?
Your response must be concise. 0.6. What is the ratio of the Debt(% of exports of goods, services and primary income) of Dominica in 2004 to that in 2005?
Keep it short and to the point. 1.11. What is the ratio of the Debt(% of exports of goods, services and primary income) in Middle East & North Africa (developing only) in 2004 to that in 2006?
Offer a very short reply. 0.98. What is the ratio of the Debt(% of exports of goods, services and primary income) in Bulgaria in 2004 to that in 2006?
Provide a short and direct response. 0.9. What is the ratio of the Debt(% of exports of goods, services and primary income) in Dominica in 2004 to that in 2006?
Your answer should be very brief. 1.06. What is the ratio of the Debt(% of exports of goods, services and primary income) in Middle East & North Africa (developing only) in 2004 to that in 2007?
Your answer should be compact. 1.75. What is the ratio of the Debt(% of exports of goods, services and primary income) in Bulgaria in 2004 to that in 2007?
Provide a short and direct response. 0.68. What is the ratio of the Debt(% of exports of goods, services and primary income) of Dominica in 2004 to that in 2007?
Offer a very short reply. 1.07. What is the ratio of the Debt(% of exports of goods, services and primary income) of Middle East & North Africa (developing only) in 2005 to that in 2006?
Make the answer very short. 0.83. What is the ratio of the Debt(% of exports of goods, services and primary income) in Bulgaria in 2005 to that in 2006?
Provide a short and direct response. 1.48. What is the ratio of the Debt(% of exports of goods, services and primary income) of Dominica in 2005 to that in 2006?
Offer a very short reply. 0.95. What is the ratio of the Debt(% of exports of goods, services and primary income) in Middle East & North Africa (developing only) in 2005 to that in 2007?
Make the answer very short. 1.48. What is the ratio of the Debt(% of exports of goods, services and primary income) in Bulgaria in 2005 to that in 2007?
Keep it short and to the point. 1.12. What is the ratio of the Debt(% of exports of goods, services and primary income) of Dominica in 2005 to that in 2007?
Provide a succinct answer. 0.96. What is the ratio of the Debt(% of exports of goods, services and primary income) of Middle East & North Africa (developing only) in 2006 to that in 2007?
Your answer should be compact. 1.79. What is the ratio of the Debt(% of exports of goods, services and primary income) in Bulgaria in 2006 to that in 2007?
Your answer should be compact. 0.75. What is the ratio of the Debt(% of exports of goods, services and primary income) in Dominica in 2006 to that in 2007?
Offer a terse response. 1.01. What is the difference between the highest and the second highest Debt(% of exports of goods, services and primary income) in Middle East & North Africa (developing only)?
Provide a succinct answer. 0.55. What is the difference between the highest and the second highest Debt(% of exports of goods, services and primary income) in Bulgaria?
Provide a short and direct response. 2.72. What is the difference between the highest and the second highest Debt(% of exports of goods, services and primary income) of Dominica?
Ensure brevity in your answer.  0.74. What is the difference between the highest and the lowest Debt(% of exports of goods, services and primary income) in Middle East & North Africa (developing only)?
Keep it short and to the point. 7.33. What is the difference between the highest and the lowest Debt(% of exports of goods, services and primary income) of Bulgaria?
Offer a terse response. 15.29. What is the difference between the highest and the lowest Debt(% of exports of goods, services and primary income) in Dominica?
Give a very brief answer. 6.83. 